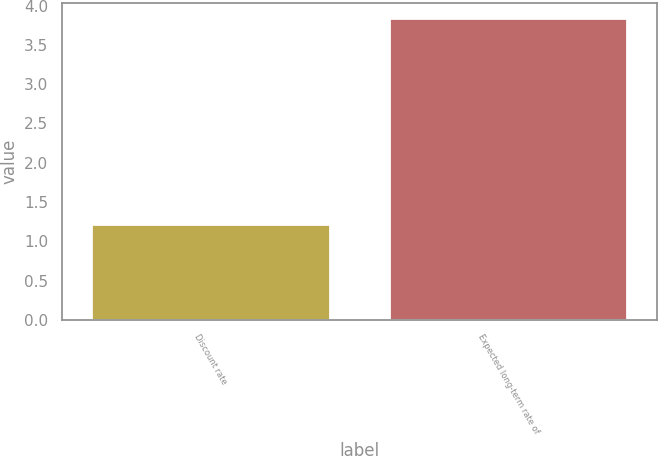Convert chart to OTSL. <chart><loc_0><loc_0><loc_500><loc_500><bar_chart><fcel>Discount rate<fcel>Expected long-term rate of<nl><fcel>1.22<fcel>3.84<nl></chart> 